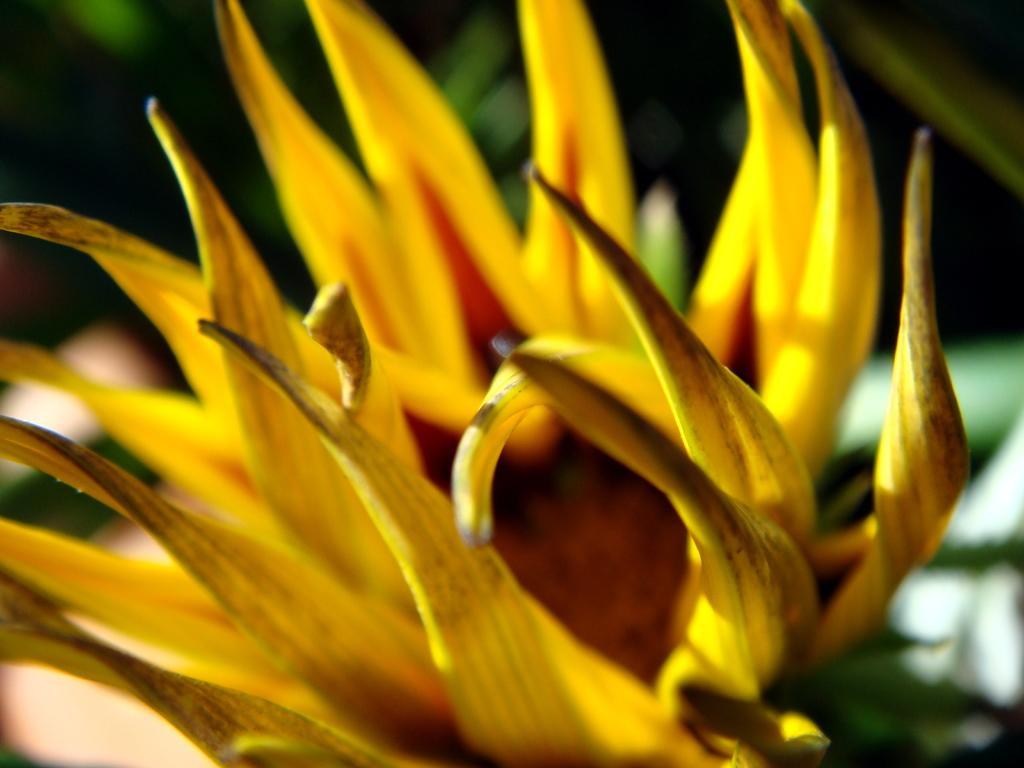Can you describe this image briefly? In the image we can see there is a yellow colour flower. 